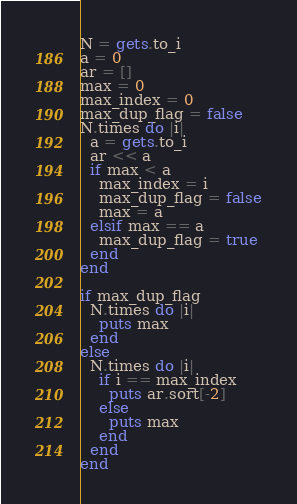<code> <loc_0><loc_0><loc_500><loc_500><_Ruby_>N = gets.to_i
a = 0
ar = []
max = 0
max_index = 0
max_dup_flag = false
N.times do |i|
  a = gets.to_i
  ar << a
  if max < a
    max_index = i
    max_dup_flag = false
    max = a
  elsif max == a
    max_dup_flag = true
  end
end

if max_dup_flag
  N.times do |i|
    puts max
  end
else
  N.times do |i|
    if i == max_index
      puts ar.sort[-2]
    else
      puts max
    end
  end
end
</code> 